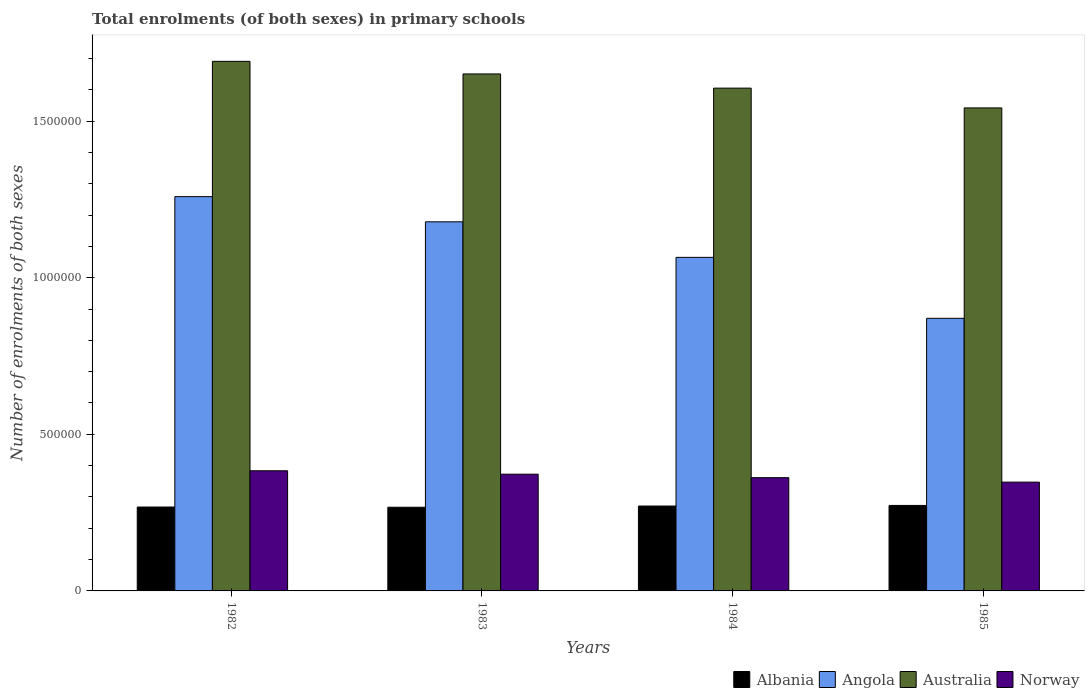How many different coloured bars are there?
Your answer should be very brief. 4. How many groups of bars are there?
Offer a terse response. 4. Are the number of bars per tick equal to the number of legend labels?
Offer a terse response. Yes. What is the label of the 2nd group of bars from the left?
Provide a succinct answer. 1983. In how many cases, is the number of bars for a given year not equal to the number of legend labels?
Provide a short and direct response. 0. What is the number of enrolments in primary schools in Angola in 1985?
Your answer should be very brief. 8.70e+05. Across all years, what is the maximum number of enrolments in primary schools in Angola?
Offer a terse response. 1.26e+06. Across all years, what is the minimum number of enrolments in primary schools in Australia?
Offer a very short reply. 1.54e+06. What is the total number of enrolments in primary schools in Angola in the graph?
Ensure brevity in your answer.  4.37e+06. What is the difference between the number of enrolments in primary schools in Norway in 1982 and that in 1985?
Your response must be concise. 3.63e+04. What is the difference between the number of enrolments in primary schools in Angola in 1985 and the number of enrolments in primary schools in Norway in 1984?
Offer a very short reply. 5.09e+05. What is the average number of enrolments in primary schools in Albania per year?
Provide a succinct answer. 2.70e+05. In the year 1985, what is the difference between the number of enrolments in primary schools in Norway and number of enrolments in primary schools in Australia?
Offer a very short reply. -1.19e+06. In how many years, is the number of enrolments in primary schools in Angola greater than 1100000?
Provide a succinct answer. 2. What is the ratio of the number of enrolments in primary schools in Angola in 1983 to that in 1984?
Provide a short and direct response. 1.11. Is the number of enrolments in primary schools in Angola in 1984 less than that in 1985?
Your response must be concise. No. What is the difference between the highest and the second highest number of enrolments in primary schools in Albania?
Make the answer very short. 1945. What is the difference between the highest and the lowest number of enrolments in primary schools in Albania?
Provide a succinct answer. 5735. In how many years, is the number of enrolments in primary schools in Australia greater than the average number of enrolments in primary schools in Australia taken over all years?
Ensure brevity in your answer.  2. What does the 4th bar from the left in 1984 represents?
Make the answer very short. Norway. What does the 1st bar from the right in 1983 represents?
Your response must be concise. Norway. Is it the case that in every year, the sum of the number of enrolments in primary schools in Norway and number of enrolments in primary schools in Albania is greater than the number of enrolments in primary schools in Australia?
Provide a succinct answer. No. How many years are there in the graph?
Ensure brevity in your answer.  4. What is the difference between two consecutive major ticks on the Y-axis?
Give a very brief answer. 5.00e+05. Does the graph contain grids?
Provide a succinct answer. No. Where does the legend appear in the graph?
Keep it short and to the point. Bottom right. How many legend labels are there?
Ensure brevity in your answer.  4. How are the legend labels stacked?
Ensure brevity in your answer.  Horizontal. What is the title of the graph?
Offer a terse response. Total enrolments (of both sexes) in primary schools. What is the label or title of the Y-axis?
Your answer should be very brief. Number of enrolments of both sexes. What is the Number of enrolments of both sexes of Albania in 1982?
Your response must be concise. 2.68e+05. What is the Number of enrolments of both sexes of Angola in 1982?
Your answer should be compact. 1.26e+06. What is the Number of enrolments of both sexes in Australia in 1982?
Keep it short and to the point. 1.69e+06. What is the Number of enrolments of both sexes of Norway in 1982?
Your response must be concise. 3.84e+05. What is the Number of enrolments of both sexes of Albania in 1983?
Make the answer very short. 2.67e+05. What is the Number of enrolments of both sexes in Angola in 1983?
Your answer should be very brief. 1.18e+06. What is the Number of enrolments of both sexes of Australia in 1983?
Keep it short and to the point. 1.65e+06. What is the Number of enrolments of both sexes of Norway in 1983?
Ensure brevity in your answer.  3.73e+05. What is the Number of enrolments of both sexes of Albania in 1984?
Your answer should be very brief. 2.71e+05. What is the Number of enrolments of both sexes in Angola in 1984?
Give a very brief answer. 1.07e+06. What is the Number of enrolments of both sexes of Australia in 1984?
Ensure brevity in your answer.  1.61e+06. What is the Number of enrolments of both sexes of Norway in 1984?
Your answer should be compact. 3.62e+05. What is the Number of enrolments of both sexes in Albania in 1985?
Provide a succinct answer. 2.73e+05. What is the Number of enrolments of both sexes in Angola in 1985?
Your response must be concise. 8.70e+05. What is the Number of enrolments of both sexes in Australia in 1985?
Provide a short and direct response. 1.54e+06. What is the Number of enrolments of both sexes in Norway in 1985?
Give a very brief answer. 3.47e+05. Across all years, what is the maximum Number of enrolments of both sexes in Albania?
Make the answer very short. 2.73e+05. Across all years, what is the maximum Number of enrolments of both sexes of Angola?
Offer a very short reply. 1.26e+06. Across all years, what is the maximum Number of enrolments of both sexes in Australia?
Your response must be concise. 1.69e+06. Across all years, what is the maximum Number of enrolments of both sexes in Norway?
Make the answer very short. 3.84e+05. Across all years, what is the minimum Number of enrolments of both sexes of Albania?
Your answer should be compact. 2.67e+05. Across all years, what is the minimum Number of enrolments of both sexes in Angola?
Offer a very short reply. 8.70e+05. Across all years, what is the minimum Number of enrolments of both sexes in Australia?
Provide a short and direct response. 1.54e+06. Across all years, what is the minimum Number of enrolments of both sexes in Norway?
Your answer should be very brief. 3.47e+05. What is the total Number of enrolments of both sexes of Albania in the graph?
Provide a succinct answer. 1.08e+06. What is the total Number of enrolments of both sexes in Angola in the graph?
Your answer should be compact. 4.37e+06. What is the total Number of enrolments of both sexes in Australia in the graph?
Your response must be concise. 6.49e+06. What is the total Number of enrolments of both sexes in Norway in the graph?
Provide a succinct answer. 1.47e+06. What is the difference between the Number of enrolments of both sexes in Albania in 1982 and that in 1983?
Ensure brevity in your answer.  650. What is the difference between the Number of enrolments of both sexes in Angola in 1982 and that in 1983?
Give a very brief answer. 8.04e+04. What is the difference between the Number of enrolments of both sexes in Australia in 1982 and that in 1983?
Keep it short and to the point. 4.02e+04. What is the difference between the Number of enrolments of both sexes in Norway in 1982 and that in 1983?
Your response must be concise. 1.09e+04. What is the difference between the Number of enrolments of both sexes of Albania in 1982 and that in 1984?
Provide a succinct answer. -3140. What is the difference between the Number of enrolments of both sexes of Angola in 1982 and that in 1984?
Offer a terse response. 1.94e+05. What is the difference between the Number of enrolments of both sexes of Australia in 1982 and that in 1984?
Your answer should be very brief. 8.55e+04. What is the difference between the Number of enrolments of both sexes of Norway in 1982 and that in 1984?
Your response must be concise. 2.20e+04. What is the difference between the Number of enrolments of both sexes of Albania in 1982 and that in 1985?
Offer a terse response. -5085. What is the difference between the Number of enrolments of both sexes of Angola in 1982 and that in 1985?
Offer a terse response. 3.88e+05. What is the difference between the Number of enrolments of both sexes of Australia in 1982 and that in 1985?
Keep it short and to the point. 1.49e+05. What is the difference between the Number of enrolments of both sexes of Norway in 1982 and that in 1985?
Offer a very short reply. 3.63e+04. What is the difference between the Number of enrolments of both sexes of Albania in 1983 and that in 1984?
Make the answer very short. -3790. What is the difference between the Number of enrolments of both sexes of Angola in 1983 and that in 1984?
Your response must be concise. 1.13e+05. What is the difference between the Number of enrolments of both sexes in Australia in 1983 and that in 1984?
Give a very brief answer. 4.53e+04. What is the difference between the Number of enrolments of both sexes in Norway in 1983 and that in 1984?
Your answer should be compact. 1.11e+04. What is the difference between the Number of enrolments of both sexes in Albania in 1983 and that in 1985?
Your answer should be compact. -5735. What is the difference between the Number of enrolments of both sexes in Angola in 1983 and that in 1985?
Your answer should be compact. 3.08e+05. What is the difference between the Number of enrolments of both sexes in Australia in 1983 and that in 1985?
Offer a very short reply. 1.08e+05. What is the difference between the Number of enrolments of both sexes of Norway in 1983 and that in 1985?
Give a very brief answer. 2.54e+04. What is the difference between the Number of enrolments of both sexes of Albania in 1984 and that in 1985?
Provide a succinct answer. -1945. What is the difference between the Number of enrolments of both sexes in Angola in 1984 and that in 1985?
Provide a succinct answer. 1.95e+05. What is the difference between the Number of enrolments of both sexes in Australia in 1984 and that in 1985?
Provide a succinct answer. 6.32e+04. What is the difference between the Number of enrolments of both sexes of Norway in 1984 and that in 1985?
Provide a succinct answer. 1.43e+04. What is the difference between the Number of enrolments of both sexes in Albania in 1982 and the Number of enrolments of both sexes in Angola in 1983?
Make the answer very short. -9.11e+05. What is the difference between the Number of enrolments of both sexes in Albania in 1982 and the Number of enrolments of both sexes in Australia in 1983?
Give a very brief answer. -1.38e+06. What is the difference between the Number of enrolments of both sexes of Albania in 1982 and the Number of enrolments of both sexes of Norway in 1983?
Your answer should be very brief. -1.05e+05. What is the difference between the Number of enrolments of both sexes in Angola in 1982 and the Number of enrolments of both sexes in Australia in 1983?
Provide a short and direct response. -3.92e+05. What is the difference between the Number of enrolments of both sexes in Angola in 1982 and the Number of enrolments of both sexes in Norway in 1983?
Make the answer very short. 8.86e+05. What is the difference between the Number of enrolments of both sexes in Australia in 1982 and the Number of enrolments of both sexes in Norway in 1983?
Make the answer very short. 1.32e+06. What is the difference between the Number of enrolments of both sexes of Albania in 1982 and the Number of enrolments of both sexes of Angola in 1984?
Offer a terse response. -7.97e+05. What is the difference between the Number of enrolments of both sexes of Albania in 1982 and the Number of enrolments of both sexes of Australia in 1984?
Your answer should be very brief. -1.34e+06. What is the difference between the Number of enrolments of both sexes in Albania in 1982 and the Number of enrolments of both sexes in Norway in 1984?
Offer a very short reply. -9.37e+04. What is the difference between the Number of enrolments of both sexes in Angola in 1982 and the Number of enrolments of both sexes in Australia in 1984?
Give a very brief answer. -3.46e+05. What is the difference between the Number of enrolments of both sexes of Angola in 1982 and the Number of enrolments of both sexes of Norway in 1984?
Your answer should be compact. 8.97e+05. What is the difference between the Number of enrolments of both sexes in Australia in 1982 and the Number of enrolments of both sexes in Norway in 1984?
Your response must be concise. 1.33e+06. What is the difference between the Number of enrolments of both sexes in Albania in 1982 and the Number of enrolments of both sexes in Angola in 1985?
Provide a succinct answer. -6.03e+05. What is the difference between the Number of enrolments of both sexes in Albania in 1982 and the Number of enrolments of both sexes in Australia in 1985?
Provide a short and direct response. -1.27e+06. What is the difference between the Number of enrolments of both sexes of Albania in 1982 and the Number of enrolments of both sexes of Norway in 1985?
Provide a succinct answer. -7.95e+04. What is the difference between the Number of enrolments of both sexes of Angola in 1982 and the Number of enrolments of both sexes of Australia in 1985?
Ensure brevity in your answer.  -2.83e+05. What is the difference between the Number of enrolments of both sexes in Angola in 1982 and the Number of enrolments of both sexes in Norway in 1985?
Keep it short and to the point. 9.12e+05. What is the difference between the Number of enrolments of both sexes in Australia in 1982 and the Number of enrolments of both sexes in Norway in 1985?
Offer a very short reply. 1.34e+06. What is the difference between the Number of enrolments of both sexes of Albania in 1983 and the Number of enrolments of both sexes of Angola in 1984?
Your response must be concise. -7.98e+05. What is the difference between the Number of enrolments of both sexes in Albania in 1983 and the Number of enrolments of both sexes in Australia in 1984?
Make the answer very short. -1.34e+06. What is the difference between the Number of enrolments of both sexes of Albania in 1983 and the Number of enrolments of both sexes of Norway in 1984?
Offer a terse response. -9.44e+04. What is the difference between the Number of enrolments of both sexes in Angola in 1983 and the Number of enrolments of both sexes in Australia in 1984?
Your response must be concise. -4.27e+05. What is the difference between the Number of enrolments of both sexes of Angola in 1983 and the Number of enrolments of both sexes of Norway in 1984?
Offer a terse response. 8.17e+05. What is the difference between the Number of enrolments of both sexes of Australia in 1983 and the Number of enrolments of both sexes of Norway in 1984?
Offer a terse response. 1.29e+06. What is the difference between the Number of enrolments of both sexes of Albania in 1983 and the Number of enrolments of both sexes of Angola in 1985?
Provide a succinct answer. -6.03e+05. What is the difference between the Number of enrolments of both sexes of Albania in 1983 and the Number of enrolments of both sexes of Australia in 1985?
Make the answer very short. -1.27e+06. What is the difference between the Number of enrolments of both sexes of Albania in 1983 and the Number of enrolments of both sexes of Norway in 1985?
Your answer should be compact. -8.01e+04. What is the difference between the Number of enrolments of both sexes in Angola in 1983 and the Number of enrolments of both sexes in Australia in 1985?
Your answer should be very brief. -3.64e+05. What is the difference between the Number of enrolments of both sexes of Angola in 1983 and the Number of enrolments of both sexes of Norway in 1985?
Make the answer very short. 8.31e+05. What is the difference between the Number of enrolments of both sexes of Australia in 1983 and the Number of enrolments of both sexes of Norway in 1985?
Offer a terse response. 1.30e+06. What is the difference between the Number of enrolments of both sexes of Albania in 1984 and the Number of enrolments of both sexes of Angola in 1985?
Keep it short and to the point. -5.99e+05. What is the difference between the Number of enrolments of both sexes in Albania in 1984 and the Number of enrolments of both sexes in Australia in 1985?
Ensure brevity in your answer.  -1.27e+06. What is the difference between the Number of enrolments of both sexes of Albania in 1984 and the Number of enrolments of both sexes of Norway in 1985?
Keep it short and to the point. -7.63e+04. What is the difference between the Number of enrolments of both sexes of Angola in 1984 and the Number of enrolments of both sexes of Australia in 1985?
Make the answer very short. -4.77e+05. What is the difference between the Number of enrolments of both sexes of Angola in 1984 and the Number of enrolments of both sexes of Norway in 1985?
Your answer should be very brief. 7.18e+05. What is the difference between the Number of enrolments of both sexes of Australia in 1984 and the Number of enrolments of both sexes of Norway in 1985?
Your answer should be very brief. 1.26e+06. What is the average Number of enrolments of both sexes in Albania per year?
Your answer should be compact. 2.70e+05. What is the average Number of enrolments of both sexes of Angola per year?
Make the answer very short. 1.09e+06. What is the average Number of enrolments of both sexes in Australia per year?
Your answer should be very brief. 1.62e+06. What is the average Number of enrolments of both sexes of Norway per year?
Provide a succinct answer. 3.66e+05. In the year 1982, what is the difference between the Number of enrolments of both sexes in Albania and Number of enrolments of both sexes in Angola?
Your answer should be very brief. -9.91e+05. In the year 1982, what is the difference between the Number of enrolments of both sexes of Albania and Number of enrolments of both sexes of Australia?
Offer a terse response. -1.42e+06. In the year 1982, what is the difference between the Number of enrolments of both sexes of Albania and Number of enrolments of both sexes of Norway?
Provide a succinct answer. -1.16e+05. In the year 1982, what is the difference between the Number of enrolments of both sexes of Angola and Number of enrolments of both sexes of Australia?
Provide a short and direct response. -4.32e+05. In the year 1982, what is the difference between the Number of enrolments of both sexes in Angola and Number of enrolments of both sexes in Norway?
Your answer should be very brief. 8.75e+05. In the year 1982, what is the difference between the Number of enrolments of both sexes of Australia and Number of enrolments of both sexes of Norway?
Make the answer very short. 1.31e+06. In the year 1983, what is the difference between the Number of enrolments of both sexes in Albania and Number of enrolments of both sexes in Angola?
Your answer should be compact. -9.11e+05. In the year 1983, what is the difference between the Number of enrolments of both sexes of Albania and Number of enrolments of both sexes of Australia?
Give a very brief answer. -1.38e+06. In the year 1983, what is the difference between the Number of enrolments of both sexes of Albania and Number of enrolments of both sexes of Norway?
Your answer should be very brief. -1.06e+05. In the year 1983, what is the difference between the Number of enrolments of both sexes of Angola and Number of enrolments of both sexes of Australia?
Your response must be concise. -4.72e+05. In the year 1983, what is the difference between the Number of enrolments of both sexes in Angola and Number of enrolments of both sexes in Norway?
Your answer should be compact. 8.06e+05. In the year 1983, what is the difference between the Number of enrolments of both sexes of Australia and Number of enrolments of both sexes of Norway?
Ensure brevity in your answer.  1.28e+06. In the year 1984, what is the difference between the Number of enrolments of both sexes in Albania and Number of enrolments of both sexes in Angola?
Keep it short and to the point. -7.94e+05. In the year 1984, what is the difference between the Number of enrolments of both sexes of Albania and Number of enrolments of both sexes of Australia?
Keep it short and to the point. -1.33e+06. In the year 1984, what is the difference between the Number of enrolments of both sexes in Albania and Number of enrolments of both sexes in Norway?
Make the answer very short. -9.06e+04. In the year 1984, what is the difference between the Number of enrolments of both sexes in Angola and Number of enrolments of both sexes in Australia?
Ensure brevity in your answer.  -5.40e+05. In the year 1984, what is the difference between the Number of enrolments of both sexes of Angola and Number of enrolments of both sexes of Norway?
Provide a succinct answer. 7.03e+05. In the year 1984, what is the difference between the Number of enrolments of both sexes in Australia and Number of enrolments of both sexes in Norway?
Provide a succinct answer. 1.24e+06. In the year 1985, what is the difference between the Number of enrolments of both sexes of Albania and Number of enrolments of both sexes of Angola?
Offer a terse response. -5.97e+05. In the year 1985, what is the difference between the Number of enrolments of both sexes of Albania and Number of enrolments of both sexes of Australia?
Your response must be concise. -1.27e+06. In the year 1985, what is the difference between the Number of enrolments of both sexes of Albania and Number of enrolments of both sexes of Norway?
Ensure brevity in your answer.  -7.44e+04. In the year 1985, what is the difference between the Number of enrolments of both sexes in Angola and Number of enrolments of both sexes in Australia?
Offer a very short reply. -6.72e+05. In the year 1985, what is the difference between the Number of enrolments of both sexes in Angola and Number of enrolments of both sexes in Norway?
Your response must be concise. 5.23e+05. In the year 1985, what is the difference between the Number of enrolments of both sexes in Australia and Number of enrolments of both sexes in Norway?
Your answer should be very brief. 1.19e+06. What is the ratio of the Number of enrolments of both sexes of Albania in 1982 to that in 1983?
Keep it short and to the point. 1. What is the ratio of the Number of enrolments of both sexes in Angola in 1982 to that in 1983?
Offer a terse response. 1.07. What is the ratio of the Number of enrolments of both sexes in Australia in 1982 to that in 1983?
Offer a very short reply. 1.02. What is the ratio of the Number of enrolments of both sexes in Norway in 1982 to that in 1983?
Your answer should be very brief. 1.03. What is the ratio of the Number of enrolments of both sexes of Albania in 1982 to that in 1984?
Ensure brevity in your answer.  0.99. What is the ratio of the Number of enrolments of both sexes in Angola in 1982 to that in 1984?
Your answer should be compact. 1.18. What is the ratio of the Number of enrolments of both sexes in Australia in 1982 to that in 1984?
Your answer should be compact. 1.05. What is the ratio of the Number of enrolments of both sexes of Norway in 1982 to that in 1984?
Offer a terse response. 1.06. What is the ratio of the Number of enrolments of both sexes in Albania in 1982 to that in 1985?
Offer a terse response. 0.98. What is the ratio of the Number of enrolments of both sexes of Angola in 1982 to that in 1985?
Your answer should be very brief. 1.45. What is the ratio of the Number of enrolments of both sexes in Australia in 1982 to that in 1985?
Ensure brevity in your answer.  1.1. What is the ratio of the Number of enrolments of both sexes in Norway in 1982 to that in 1985?
Give a very brief answer. 1.1. What is the ratio of the Number of enrolments of both sexes in Angola in 1983 to that in 1984?
Offer a terse response. 1.11. What is the ratio of the Number of enrolments of both sexes of Australia in 1983 to that in 1984?
Your answer should be very brief. 1.03. What is the ratio of the Number of enrolments of both sexes of Norway in 1983 to that in 1984?
Your answer should be very brief. 1.03. What is the ratio of the Number of enrolments of both sexes of Albania in 1983 to that in 1985?
Ensure brevity in your answer.  0.98. What is the ratio of the Number of enrolments of both sexes in Angola in 1983 to that in 1985?
Provide a succinct answer. 1.35. What is the ratio of the Number of enrolments of both sexes of Australia in 1983 to that in 1985?
Provide a short and direct response. 1.07. What is the ratio of the Number of enrolments of both sexes of Norway in 1983 to that in 1985?
Offer a very short reply. 1.07. What is the ratio of the Number of enrolments of both sexes in Albania in 1984 to that in 1985?
Keep it short and to the point. 0.99. What is the ratio of the Number of enrolments of both sexes of Angola in 1984 to that in 1985?
Offer a terse response. 1.22. What is the ratio of the Number of enrolments of both sexes in Australia in 1984 to that in 1985?
Provide a succinct answer. 1.04. What is the ratio of the Number of enrolments of both sexes of Norway in 1984 to that in 1985?
Ensure brevity in your answer.  1.04. What is the difference between the highest and the second highest Number of enrolments of both sexes in Albania?
Offer a very short reply. 1945. What is the difference between the highest and the second highest Number of enrolments of both sexes in Angola?
Provide a succinct answer. 8.04e+04. What is the difference between the highest and the second highest Number of enrolments of both sexes in Australia?
Your answer should be very brief. 4.02e+04. What is the difference between the highest and the second highest Number of enrolments of both sexes in Norway?
Give a very brief answer. 1.09e+04. What is the difference between the highest and the lowest Number of enrolments of both sexes of Albania?
Your answer should be compact. 5735. What is the difference between the highest and the lowest Number of enrolments of both sexes in Angola?
Make the answer very short. 3.88e+05. What is the difference between the highest and the lowest Number of enrolments of both sexes in Australia?
Offer a terse response. 1.49e+05. What is the difference between the highest and the lowest Number of enrolments of both sexes in Norway?
Make the answer very short. 3.63e+04. 